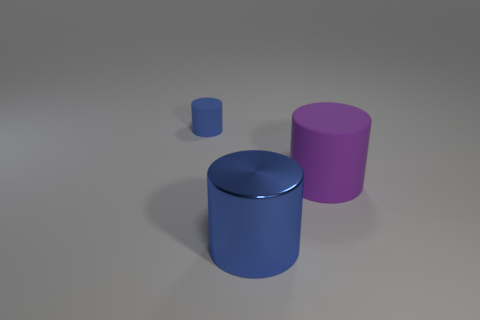Are there any other things that are the same size as the blue rubber object?
Make the answer very short. No. Does the cylinder on the left side of the big blue cylinder have the same color as the big shiny thing that is in front of the large purple thing?
Your response must be concise. Yes. What size is the blue rubber cylinder?
Your answer should be very brief. Small. What size is the cylinder that is behind the large purple matte cylinder?
Make the answer very short. Small. Is there another big blue cylinder that has the same material as the large blue cylinder?
Provide a short and direct response. No. There is another cylinder that is the same color as the small cylinder; what size is it?
Give a very brief answer. Large. What number of cylinders are either large metal objects or large purple objects?
Ensure brevity in your answer.  2. Are there more blue cylinders that are to the right of the blue matte cylinder than purple matte cylinders that are left of the large rubber thing?
Your response must be concise. Yes. How many other small cylinders have the same color as the shiny cylinder?
Give a very brief answer. 1. There is another purple cylinder that is made of the same material as the tiny cylinder; what size is it?
Offer a very short reply. Large. 